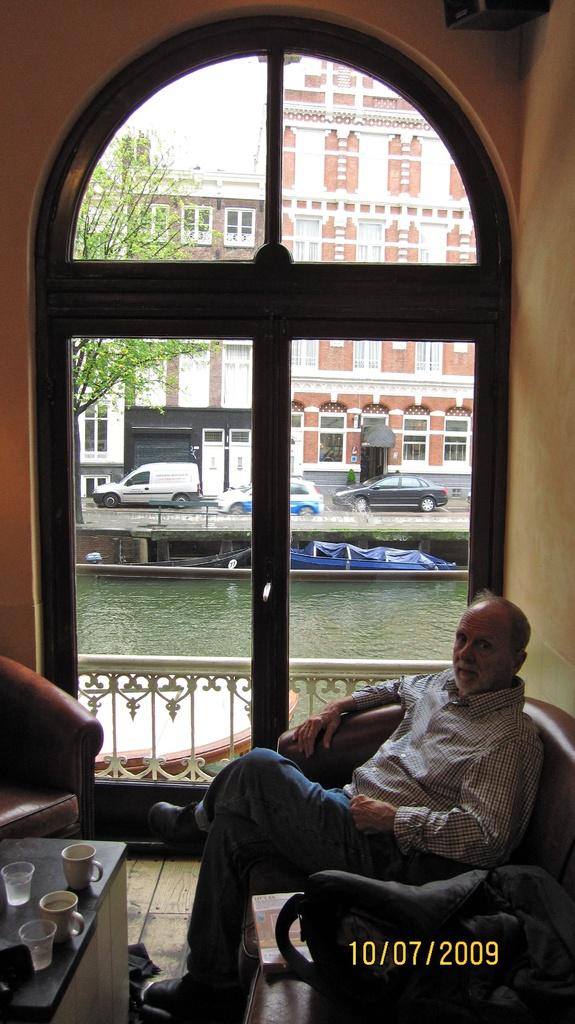What is the man in the image doing? The man is sitting on the sofa. Where is the man positioned in relation to the table? The man is in front of a table. How many cups are on the table? There are two cups on the table. What else is on the table besides the cups? There are gas bottles on the table. What can be seen beside the man? There is a window beside the man. Who is the servant attending to in the image? There is no servant present in the image. What type of ray is visible in the image? There is no ray visible in the image. 